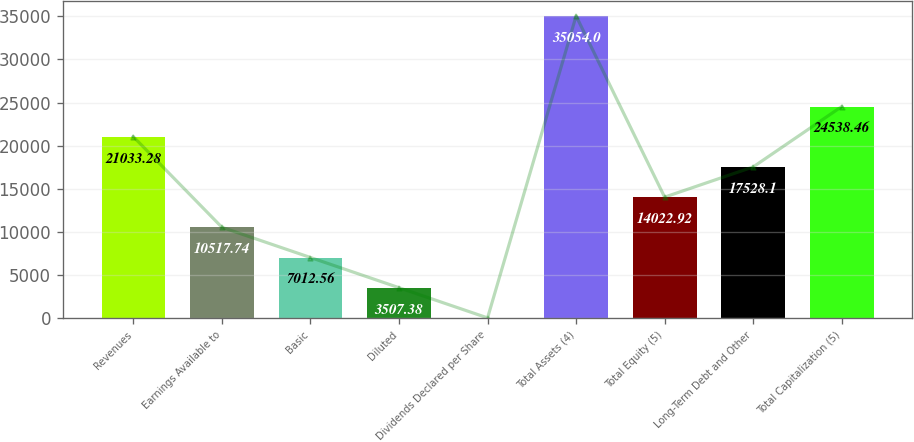<chart> <loc_0><loc_0><loc_500><loc_500><bar_chart><fcel>Revenues<fcel>Earnings Available to<fcel>Basic<fcel>Diluted<fcel>Dividends Declared per Share<fcel>Total Assets (4)<fcel>Total Equity (5)<fcel>Long-Term Debt and Other<fcel>Total Capitalization (5)<nl><fcel>21033.3<fcel>10517.7<fcel>7012.56<fcel>3507.38<fcel>2.2<fcel>35054<fcel>14022.9<fcel>17528.1<fcel>24538.5<nl></chart> 